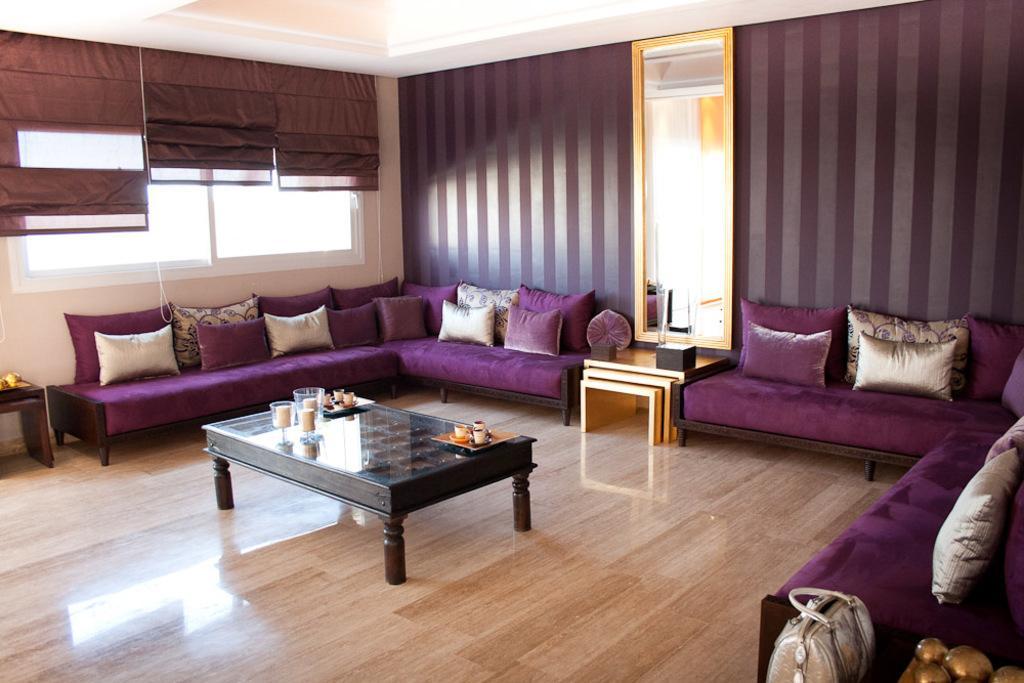Describe this image in one or two sentences. In this picture we can see a wooden floor and on the floor there are tables and couches. On the table there are trays, cups and other things and on the couches there are cushions. On the right side of the table there is a mirror and on the left side of the couches there is a glass window with some items. 